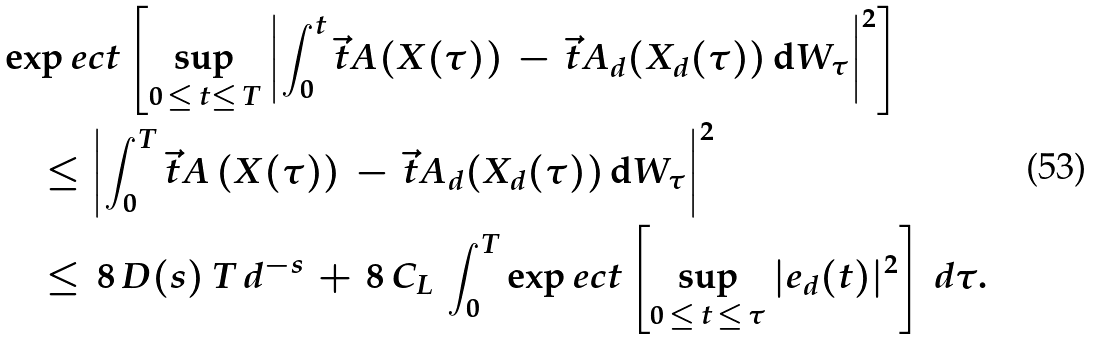<formula> <loc_0><loc_0><loc_500><loc_500>& \exp e c t \left [ \sup _ { 0 \, \leq \, t \leq \, T } \left | \int _ { 0 } ^ { t } \vec { t } A ( X ( \tau ) ) \, - \, \vec { t } A _ { d } ( X _ { d } ( \tau ) ) \, \mathrm d W _ { \tau } \right | ^ { 2 } \right ] \\ & \quad \leq \left | \int _ { 0 } ^ { T } \vec { t } A \, ( X ( \tau ) ) \, - \, \vec { t } A _ { d } ( X _ { d } ( \tau ) ) \, \mathrm d W _ { \tau } \right | ^ { 2 } \\ & \quad \leq \, 8 \, D ( s ) \, T \, d ^ { - s } \, + \, 8 \, C _ { L } \, \int _ { 0 } ^ { T } \exp e c t \left [ \sup _ { 0 \, \leq \, t \, \leq \, \tau } | e _ { d } ( t ) | ^ { 2 } \right ] \, d \tau .</formula> 